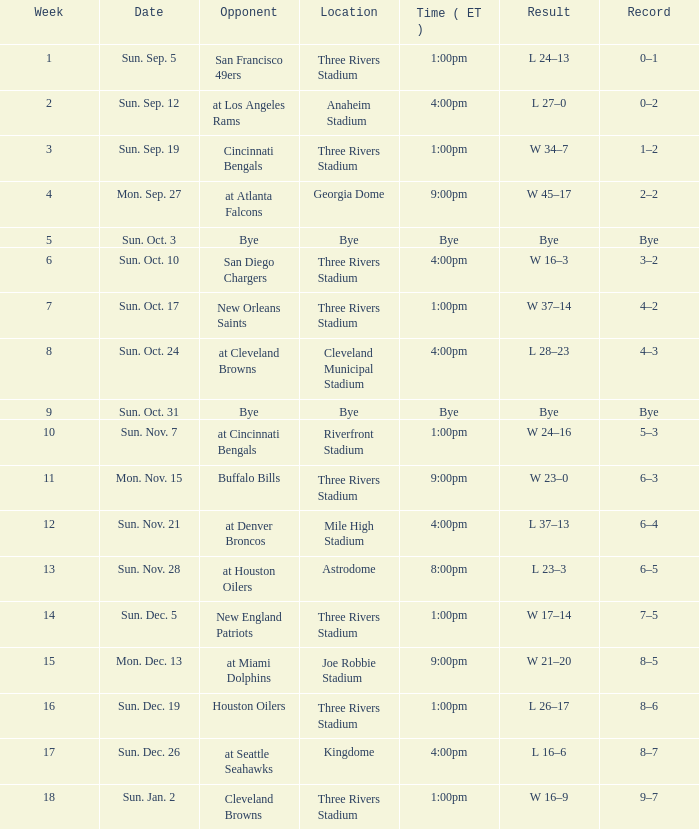What is the average Week for the game at three rivers stadium, with a Record of 3–2? 6.0. 